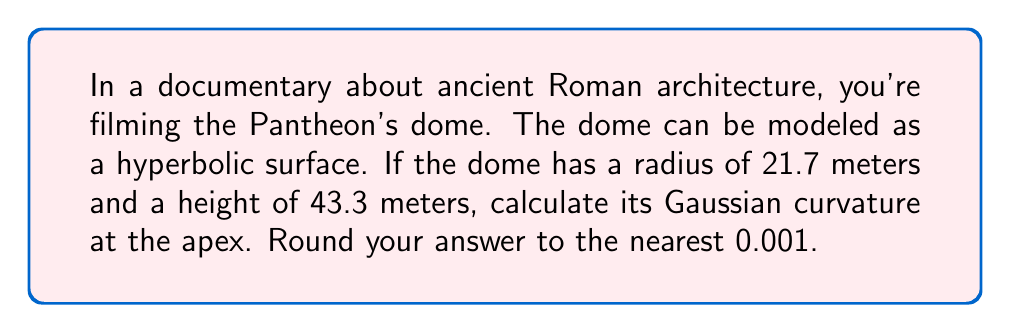Give your solution to this math problem. To calculate the Gaussian curvature of the hyperbolic surface at the apex of the Pantheon's dome, we'll follow these steps:

1. The hyperbolic surface can be modeled using the equation:

   $$ z = \frac{x^2}{a^2} - \frac{y^2}{b^2} $$

   where $a$ and $b$ are constants we need to determine.

2. We know the radius (r) and height (h) of the dome:
   r = 21.7 m
   h = 43.3 m

3. We can relate these to our hyperbolic model:

   $$ h = \frac{r^2}{a^2} $$

4. Solving for $a$:

   $$ a^2 = \frac{r^2}{h} = \frac{21.7^2}{43.3} = 10.85 $$
   $$ a = \sqrt{10.85} \approx 3.294 $$

5. For a hyperbolic surface of revolution, $b = a$, so $b \approx 3.294$ as well.

6. The Gaussian curvature (K) at the apex (0,0) of a hyperbolic surface is given by:

   $$ K = -\frac{4}{a^2} $$

7. Substituting our value for $a$:

   $$ K = -\frac{4}{3.294^2} \approx -0.3683 $$

8. Rounding to the nearest 0.001:

   $$ K \approx -0.368 $$
Answer: $-0.368 \text{ m}^{-2}$ 